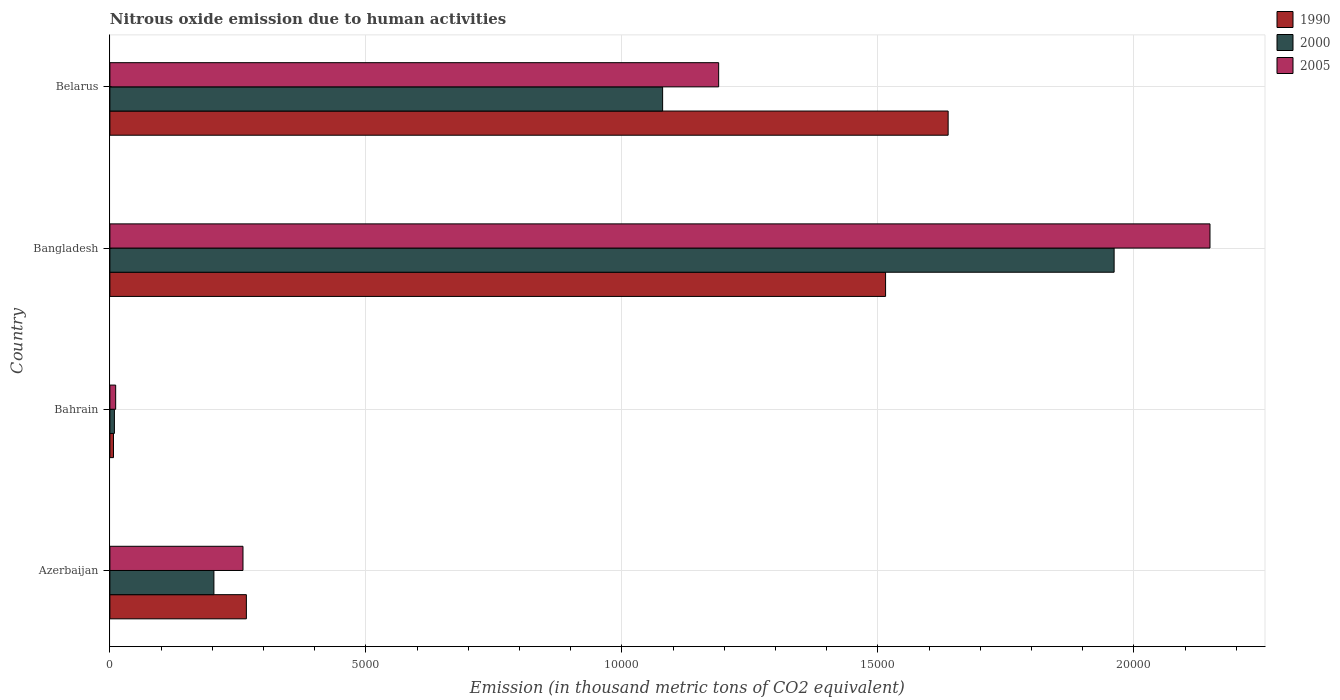How many groups of bars are there?
Provide a short and direct response. 4. How many bars are there on the 3rd tick from the top?
Ensure brevity in your answer.  3. How many bars are there on the 2nd tick from the bottom?
Your response must be concise. 3. What is the amount of nitrous oxide emitted in 2000 in Bahrain?
Give a very brief answer. 88.2. Across all countries, what is the maximum amount of nitrous oxide emitted in 1990?
Offer a very short reply. 1.64e+04. Across all countries, what is the minimum amount of nitrous oxide emitted in 2005?
Provide a succinct answer. 112.9. In which country was the amount of nitrous oxide emitted in 1990 maximum?
Your answer should be very brief. Belarus. In which country was the amount of nitrous oxide emitted in 2000 minimum?
Give a very brief answer. Bahrain. What is the total amount of nitrous oxide emitted in 2005 in the graph?
Give a very brief answer. 3.61e+04. What is the difference between the amount of nitrous oxide emitted in 2000 in Bahrain and that in Belarus?
Offer a terse response. -1.07e+04. What is the difference between the amount of nitrous oxide emitted in 1990 in Bangladesh and the amount of nitrous oxide emitted in 2000 in Bahrain?
Provide a succinct answer. 1.51e+04. What is the average amount of nitrous oxide emitted in 2005 per country?
Provide a short and direct response. 9022.35. What is the difference between the amount of nitrous oxide emitted in 2000 and amount of nitrous oxide emitted in 1990 in Azerbaijan?
Provide a short and direct response. -634.1. What is the ratio of the amount of nitrous oxide emitted in 2005 in Azerbaijan to that in Bahrain?
Make the answer very short. 23.03. Is the difference between the amount of nitrous oxide emitted in 2000 in Bahrain and Belarus greater than the difference between the amount of nitrous oxide emitted in 1990 in Bahrain and Belarus?
Offer a very short reply. Yes. What is the difference between the highest and the second highest amount of nitrous oxide emitted in 2005?
Offer a very short reply. 9596.5. What is the difference between the highest and the lowest amount of nitrous oxide emitted in 2005?
Your response must be concise. 2.14e+04. In how many countries, is the amount of nitrous oxide emitted in 1990 greater than the average amount of nitrous oxide emitted in 1990 taken over all countries?
Give a very brief answer. 2. What does the 2nd bar from the bottom in Belarus represents?
Offer a very short reply. 2000. Is it the case that in every country, the sum of the amount of nitrous oxide emitted in 2005 and amount of nitrous oxide emitted in 2000 is greater than the amount of nitrous oxide emitted in 1990?
Your response must be concise. Yes. Are all the bars in the graph horizontal?
Make the answer very short. Yes. What is the difference between two consecutive major ticks on the X-axis?
Provide a short and direct response. 5000. Are the values on the major ticks of X-axis written in scientific E-notation?
Keep it short and to the point. No. Does the graph contain any zero values?
Give a very brief answer. No. Does the graph contain grids?
Offer a terse response. Yes. How many legend labels are there?
Provide a succinct answer. 3. How are the legend labels stacked?
Your answer should be very brief. Vertical. What is the title of the graph?
Provide a succinct answer. Nitrous oxide emission due to human activities. Does "1972" appear as one of the legend labels in the graph?
Provide a succinct answer. No. What is the label or title of the X-axis?
Your answer should be compact. Emission (in thousand metric tons of CO2 equivalent). What is the label or title of the Y-axis?
Provide a short and direct response. Country. What is the Emission (in thousand metric tons of CO2 equivalent) of 1990 in Azerbaijan?
Your response must be concise. 2665.8. What is the Emission (in thousand metric tons of CO2 equivalent) in 2000 in Azerbaijan?
Your answer should be compact. 2031.7. What is the Emission (in thousand metric tons of CO2 equivalent) in 2005 in Azerbaijan?
Offer a terse response. 2599.6. What is the Emission (in thousand metric tons of CO2 equivalent) of 1990 in Bahrain?
Ensure brevity in your answer.  70.2. What is the Emission (in thousand metric tons of CO2 equivalent) of 2000 in Bahrain?
Your response must be concise. 88.2. What is the Emission (in thousand metric tons of CO2 equivalent) of 2005 in Bahrain?
Give a very brief answer. 112.9. What is the Emission (in thousand metric tons of CO2 equivalent) of 1990 in Bangladesh?
Make the answer very short. 1.52e+04. What is the Emission (in thousand metric tons of CO2 equivalent) of 2000 in Bangladesh?
Your answer should be very brief. 1.96e+04. What is the Emission (in thousand metric tons of CO2 equivalent) in 2005 in Bangladesh?
Offer a terse response. 2.15e+04. What is the Emission (in thousand metric tons of CO2 equivalent) of 1990 in Belarus?
Offer a very short reply. 1.64e+04. What is the Emission (in thousand metric tons of CO2 equivalent) of 2000 in Belarus?
Your response must be concise. 1.08e+04. What is the Emission (in thousand metric tons of CO2 equivalent) of 2005 in Belarus?
Ensure brevity in your answer.  1.19e+04. Across all countries, what is the maximum Emission (in thousand metric tons of CO2 equivalent) of 1990?
Offer a terse response. 1.64e+04. Across all countries, what is the maximum Emission (in thousand metric tons of CO2 equivalent) of 2000?
Provide a short and direct response. 1.96e+04. Across all countries, what is the maximum Emission (in thousand metric tons of CO2 equivalent) of 2005?
Your answer should be very brief. 2.15e+04. Across all countries, what is the minimum Emission (in thousand metric tons of CO2 equivalent) of 1990?
Your answer should be very brief. 70.2. Across all countries, what is the minimum Emission (in thousand metric tons of CO2 equivalent) in 2000?
Keep it short and to the point. 88.2. Across all countries, what is the minimum Emission (in thousand metric tons of CO2 equivalent) of 2005?
Provide a succinct answer. 112.9. What is the total Emission (in thousand metric tons of CO2 equivalent) of 1990 in the graph?
Give a very brief answer. 3.43e+04. What is the total Emission (in thousand metric tons of CO2 equivalent) in 2000 in the graph?
Provide a short and direct response. 3.25e+04. What is the total Emission (in thousand metric tons of CO2 equivalent) in 2005 in the graph?
Offer a very short reply. 3.61e+04. What is the difference between the Emission (in thousand metric tons of CO2 equivalent) in 1990 in Azerbaijan and that in Bahrain?
Provide a short and direct response. 2595.6. What is the difference between the Emission (in thousand metric tons of CO2 equivalent) of 2000 in Azerbaijan and that in Bahrain?
Provide a short and direct response. 1943.5. What is the difference between the Emission (in thousand metric tons of CO2 equivalent) in 2005 in Azerbaijan and that in Bahrain?
Offer a very short reply. 2486.7. What is the difference between the Emission (in thousand metric tons of CO2 equivalent) of 1990 in Azerbaijan and that in Bangladesh?
Offer a very short reply. -1.25e+04. What is the difference between the Emission (in thousand metric tons of CO2 equivalent) of 2000 in Azerbaijan and that in Bangladesh?
Your answer should be very brief. -1.76e+04. What is the difference between the Emission (in thousand metric tons of CO2 equivalent) in 2005 in Azerbaijan and that in Bangladesh?
Keep it short and to the point. -1.89e+04. What is the difference between the Emission (in thousand metric tons of CO2 equivalent) of 1990 in Azerbaijan and that in Belarus?
Keep it short and to the point. -1.37e+04. What is the difference between the Emission (in thousand metric tons of CO2 equivalent) of 2000 in Azerbaijan and that in Belarus?
Your response must be concise. -8764.2. What is the difference between the Emission (in thousand metric tons of CO2 equivalent) of 2005 in Azerbaijan and that in Belarus?
Make the answer very short. -9290.6. What is the difference between the Emission (in thousand metric tons of CO2 equivalent) of 1990 in Bahrain and that in Bangladesh?
Your answer should be very brief. -1.51e+04. What is the difference between the Emission (in thousand metric tons of CO2 equivalent) of 2000 in Bahrain and that in Bangladesh?
Your response must be concise. -1.95e+04. What is the difference between the Emission (in thousand metric tons of CO2 equivalent) in 2005 in Bahrain and that in Bangladesh?
Your response must be concise. -2.14e+04. What is the difference between the Emission (in thousand metric tons of CO2 equivalent) of 1990 in Bahrain and that in Belarus?
Provide a succinct answer. -1.63e+04. What is the difference between the Emission (in thousand metric tons of CO2 equivalent) in 2000 in Bahrain and that in Belarus?
Keep it short and to the point. -1.07e+04. What is the difference between the Emission (in thousand metric tons of CO2 equivalent) in 2005 in Bahrain and that in Belarus?
Offer a very short reply. -1.18e+04. What is the difference between the Emission (in thousand metric tons of CO2 equivalent) of 1990 in Bangladesh and that in Belarus?
Provide a short and direct response. -1221.7. What is the difference between the Emission (in thousand metric tons of CO2 equivalent) in 2000 in Bangladesh and that in Belarus?
Ensure brevity in your answer.  8818.3. What is the difference between the Emission (in thousand metric tons of CO2 equivalent) in 2005 in Bangladesh and that in Belarus?
Keep it short and to the point. 9596.5. What is the difference between the Emission (in thousand metric tons of CO2 equivalent) in 1990 in Azerbaijan and the Emission (in thousand metric tons of CO2 equivalent) in 2000 in Bahrain?
Provide a short and direct response. 2577.6. What is the difference between the Emission (in thousand metric tons of CO2 equivalent) of 1990 in Azerbaijan and the Emission (in thousand metric tons of CO2 equivalent) of 2005 in Bahrain?
Offer a very short reply. 2552.9. What is the difference between the Emission (in thousand metric tons of CO2 equivalent) in 2000 in Azerbaijan and the Emission (in thousand metric tons of CO2 equivalent) in 2005 in Bahrain?
Make the answer very short. 1918.8. What is the difference between the Emission (in thousand metric tons of CO2 equivalent) of 1990 in Azerbaijan and the Emission (in thousand metric tons of CO2 equivalent) of 2000 in Bangladesh?
Your answer should be very brief. -1.69e+04. What is the difference between the Emission (in thousand metric tons of CO2 equivalent) in 1990 in Azerbaijan and the Emission (in thousand metric tons of CO2 equivalent) in 2005 in Bangladesh?
Offer a very short reply. -1.88e+04. What is the difference between the Emission (in thousand metric tons of CO2 equivalent) of 2000 in Azerbaijan and the Emission (in thousand metric tons of CO2 equivalent) of 2005 in Bangladesh?
Provide a succinct answer. -1.95e+04. What is the difference between the Emission (in thousand metric tons of CO2 equivalent) of 1990 in Azerbaijan and the Emission (in thousand metric tons of CO2 equivalent) of 2000 in Belarus?
Your answer should be compact. -8130.1. What is the difference between the Emission (in thousand metric tons of CO2 equivalent) in 1990 in Azerbaijan and the Emission (in thousand metric tons of CO2 equivalent) in 2005 in Belarus?
Your response must be concise. -9224.4. What is the difference between the Emission (in thousand metric tons of CO2 equivalent) in 2000 in Azerbaijan and the Emission (in thousand metric tons of CO2 equivalent) in 2005 in Belarus?
Your answer should be compact. -9858.5. What is the difference between the Emission (in thousand metric tons of CO2 equivalent) in 1990 in Bahrain and the Emission (in thousand metric tons of CO2 equivalent) in 2000 in Bangladesh?
Make the answer very short. -1.95e+04. What is the difference between the Emission (in thousand metric tons of CO2 equivalent) in 1990 in Bahrain and the Emission (in thousand metric tons of CO2 equivalent) in 2005 in Bangladesh?
Keep it short and to the point. -2.14e+04. What is the difference between the Emission (in thousand metric tons of CO2 equivalent) of 2000 in Bahrain and the Emission (in thousand metric tons of CO2 equivalent) of 2005 in Bangladesh?
Keep it short and to the point. -2.14e+04. What is the difference between the Emission (in thousand metric tons of CO2 equivalent) in 1990 in Bahrain and the Emission (in thousand metric tons of CO2 equivalent) in 2000 in Belarus?
Make the answer very short. -1.07e+04. What is the difference between the Emission (in thousand metric tons of CO2 equivalent) of 1990 in Bahrain and the Emission (in thousand metric tons of CO2 equivalent) of 2005 in Belarus?
Offer a very short reply. -1.18e+04. What is the difference between the Emission (in thousand metric tons of CO2 equivalent) in 2000 in Bahrain and the Emission (in thousand metric tons of CO2 equivalent) in 2005 in Belarus?
Provide a succinct answer. -1.18e+04. What is the difference between the Emission (in thousand metric tons of CO2 equivalent) of 1990 in Bangladesh and the Emission (in thousand metric tons of CO2 equivalent) of 2000 in Belarus?
Your answer should be compact. 4354.7. What is the difference between the Emission (in thousand metric tons of CO2 equivalent) of 1990 in Bangladesh and the Emission (in thousand metric tons of CO2 equivalent) of 2005 in Belarus?
Your answer should be compact. 3260.4. What is the difference between the Emission (in thousand metric tons of CO2 equivalent) of 2000 in Bangladesh and the Emission (in thousand metric tons of CO2 equivalent) of 2005 in Belarus?
Offer a terse response. 7724. What is the average Emission (in thousand metric tons of CO2 equivalent) of 1990 per country?
Provide a succinct answer. 8564.73. What is the average Emission (in thousand metric tons of CO2 equivalent) of 2000 per country?
Your answer should be very brief. 8132.5. What is the average Emission (in thousand metric tons of CO2 equivalent) in 2005 per country?
Provide a succinct answer. 9022.35. What is the difference between the Emission (in thousand metric tons of CO2 equivalent) of 1990 and Emission (in thousand metric tons of CO2 equivalent) of 2000 in Azerbaijan?
Your answer should be very brief. 634.1. What is the difference between the Emission (in thousand metric tons of CO2 equivalent) in 1990 and Emission (in thousand metric tons of CO2 equivalent) in 2005 in Azerbaijan?
Your answer should be compact. 66.2. What is the difference between the Emission (in thousand metric tons of CO2 equivalent) in 2000 and Emission (in thousand metric tons of CO2 equivalent) in 2005 in Azerbaijan?
Your response must be concise. -567.9. What is the difference between the Emission (in thousand metric tons of CO2 equivalent) in 1990 and Emission (in thousand metric tons of CO2 equivalent) in 2005 in Bahrain?
Provide a short and direct response. -42.7. What is the difference between the Emission (in thousand metric tons of CO2 equivalent) of 2000 and Emission (in thousand metric tons of CO2 equivalent) of 2005 in Bahrain?
Provide a succinct answer. -24.7. What is the difference between the Emission (in thousand metric tons of CO2 equivalent) of 1990 and Emission (in thousand metric tons of CO2 equivalent) of 2000 in Bangladesh?
Provide a short and direct response. -4463.6. What is the difference between the Emission (in thousand metric tons of CO2 equivalent) in 1990 and Emission (in thousand metric tons of CO2 equivalent) in 2005 in Bangladesh?
Give a very brief answer. -6336.1. What is the difference between the Emission (in thousand metric tons of CO2 equivalent) in 2000 and Emission (in thousand metric tons of CO2 equivalent) in 2005 in Bangladesh?
Provide a short and direct response. -1872.5. What is the difference between the Emission (in thousand metric tons of CO2 equivalent) of 1990 and Emission (in thousand metric tons of CO2 equivalent) of 2000 in Belarus?
Your answer should be compact. 5576.4. What is the difference between the Emission (in thousand metric tons of CO2 equivalent) of 1990 and Emission (in thousand metric tons of CO2 equivalent) of 2005 in Belarus?
Provide a succinct answer. 4482.1. What is the difference between the Emission (in thousand metric tons of CO2 equivalent) of 2000 and Emission (in thousand metric tons of CO2 equivalent) of 2005 in Belarus?
Offer a terse response. -1094.3. What is the ratio of the Emission (in thousand metric tons of CO2 equivalent) of 1990 in Azerbaijan to that in Bahrain?
Your response must be concise. 37.97. What is the ratio of the Emission (in thousand metric tons of CO2 equivalent) in 2000 in Azerbaijan to that in Bahrain?
Ensure brevity in your answer.  23.04. What is the ratio of the Emission (in thousand metric tons of CO2 equivalent) in 2005 in Azerbaijan to that in Bahrain?
Offer a very short reply. 23.03. What is the ratio of the Emission (in thousand metric tons of CO2 equivalent) of 1990 in Azerbaijan to that in Bangladesh?
Ensure brevity in your answer.  0.18. What is the ratio of the Emission (in thousand metric tons of CO2 equivalent) in 2000 in Azerbaijan to that in Bangladesh?
Give a very brief answer. 0.1. What is the ratio of the Emission (in thousand metric tons of CO2 equivalent) of 2005 in Azerbaijan to that in Bangladesh?
Your answer should be compact. 0.12. What is the ratio of the Emission (in thousand metric tons of CO2 equivalent) of 1990 in Azerbaijan to that in Belarus?
Your answer should be compact. 0.16. What is the ratio of the Emission (in thousand metric tons of CO2 equivalent) of 2000 in Azerbaijan to that in Belarus?
Your answer should be compact. 0.19. What is the ratio of the Emission (in thousand metric tons of CO2 equivalent) in 2005 in Azerbaijan to that in Belarus?
Ensure brevity in your answer.  0.22. What is the ratio of the Emission (in thousand metric tons of CO2 equivalent) of 1990 in Bahrain to that in Bangladesh?
Provide a succinct answer. 0. What is the ratio of the Emission (in thousand metric tons of CO2 equivalent) in 2000 in Bahrain to that in Bangladesh?
Give a very brief answer. 0. What is the ratio of the Emission (in thousand metric tons of CO2 equivalent) in 2005 in Bahrain to that in Bangladesh?
Your response must be concise. 0.01. What is the ratio of the Emission (in thousand metric tons of CO2 equivalent) in 1990 in Bahrain to that in Belarus?
Make the answer very short. 0. What is the ratio of the Emission (in thousand metric tons of CO2 equivalent) of 2000 in Bahrain to that in Belarus?
Offer a terse response. 0.01. What is the ratio of the Emission (in thousand metric tons of CO2 equivalent) of 2005 in Bahrain to that in Belarus?
Keep it short and to the point. 0.01. What is the ratio of the Emission (in thousand metric tons of CO2 equivalent) of 1990 in Bangladesh to that in Belarus?
Provide a short and direct response. 0.93. What is the ratio of the Emission (in thousand metric tons of CO2 equivalent) in 2000 in Bangladesh to that in Belarus?
Provide a short and direct response. 1.82. What is the ratio of the Emission (in thousand metric tons of CO2 equivalent) in 2005 in Bangladesh to that in Belarus?
Give a very brief answer. 1.81. What is the difference between the highest and the second highest Emission (in thousand metric tons of CO2 equivalent) of 1990?
Offer a very short reply. 1221.7. What is the difference between the highest and the second highest Emission (in thousand metric tons of CO2 equivalent) of 2000?
Offer a very short reply. 8818.3. What is the difference between the highest and the second highest Emission (in thousand metric tons of CO2 equivalent) of 2005?
Give a very brief answer. 9596.5. What is the difference between the highest and the lowest Emission (in thousand metric tons of CO2 equivalent) of 1990?
Offer a terse response. 1.63e+04. What is the difference between the highest and the lowest Emission (in thousand metric tons of CO2 equivalent) of 2000?
Provide a succinct answer. 1.95e+04. What is the difference between the highest and the lowest Emission (in thousand metric tons of CO2 equivalent) in 2005?
Make the answer very short. 2.14e+04. 